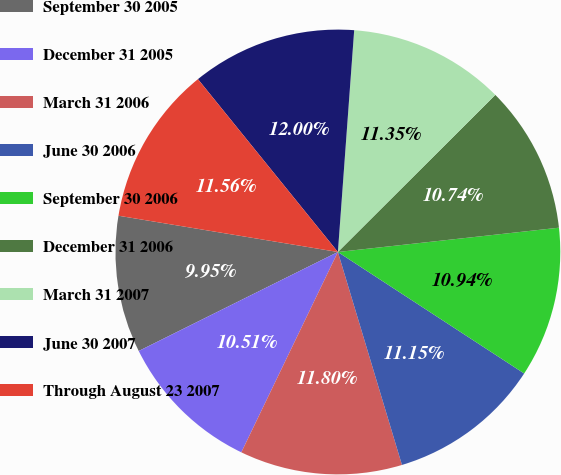Convert chart. <chart><loc_0><loc_0><loc_500><loc_500><pie_chart><fcel>September 30 2005<fcel>December 31 2005<fcel>March 31 2006<fcel>June 30 2006<fcel>September 30 2006<fcel>December 31 2006<fcel>March 31 2007<fcel>June 30 2007<fcel>Through August 23 2007<nl><fcel>9.95%<fcel>10.51%<fcel>11.8%<fcel>11.15%<fcel>10.94%<fcel>10.74%<fcel>11.35%<fcel>12.0%<fcel>11.56%<nl></chart> 